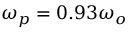<formula> <loc_0><loc_0><loc_500><loc_500>\omega _ { p } = 0 . 9 3 \omega _ { o }</formula> 